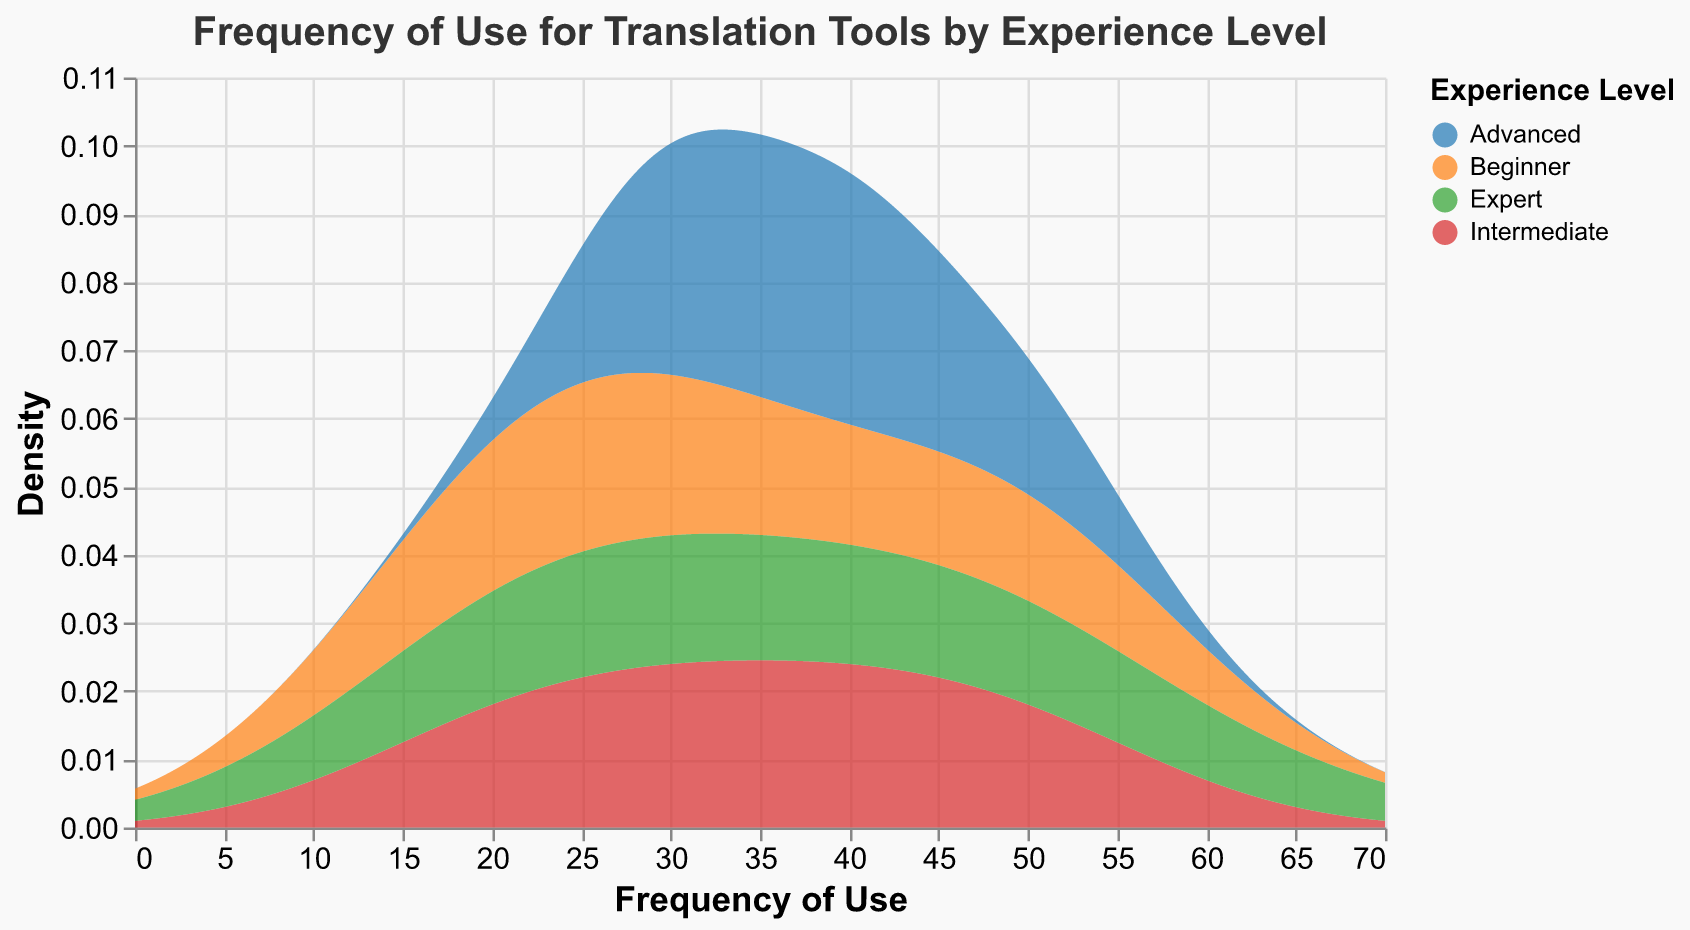What's the title of the figure? The title of the figure is located at the top and usually describes the content or purpose of the figure.
Answer: Frequency of Use for Translation Tools by Experience Level How many experience levels are represented in the plot? By counting the different colors or checking the legend, we can see there are five experience levels: Beginner, Intermediate, Advanced, Expert, and one more.
Answer: Five Which translation tool has the highest frequency of use for Beginners? The density peaks for each experience level indicate the most frequently used translation tool. The peak for Beginners aligns with Google Translate, with a frequency of use of 50.
Answer: Google Translate For which experience level is SDL Trados most frequently used? The density peak for SDL Trados aligns with the 'Advanced' experience level, hitting a frequency of 50.
Answer: Advanced How does the frequency of use for Google Translate change with increasing experience levels? By tracking the density peaks for Google Translate across experience levels, we see it starts high at Beginner (50), then decreases at each successive level (Intermediate 40, Advanced 30, Expert 20).
Answer: Decreases Which experience level has the widest range of tool usage frequencies? By observing the horizontal spread of the density plots, the 'Expert' level seems to cover a wider range (from around 20 to 60) as compared to the other levels.
Answer: Expert What is the general trend in the frequency of use for DeepL as experience increases? By comparing the density peaks: Beginner (30), Intermediate (50), Advanced (40), Expert (30), we notice that DeepL's frequency is irregular but highest at the Intermediate level.
Answer: Irregular but peaking at Intermediate Which two tools are used with equal maximum frequency by Experts? The peaks in the density plot for Experts are the same (50) for both SDL Trados and MemoQ.
Answer: SDL Trados and MemoQ Which experience level uses the most diverse set of tools? By analyzing the legend and density spread, 'Expert' level uses the most diverse set of tools, as indicated by the presence of six different tools.
Answer: Expert 